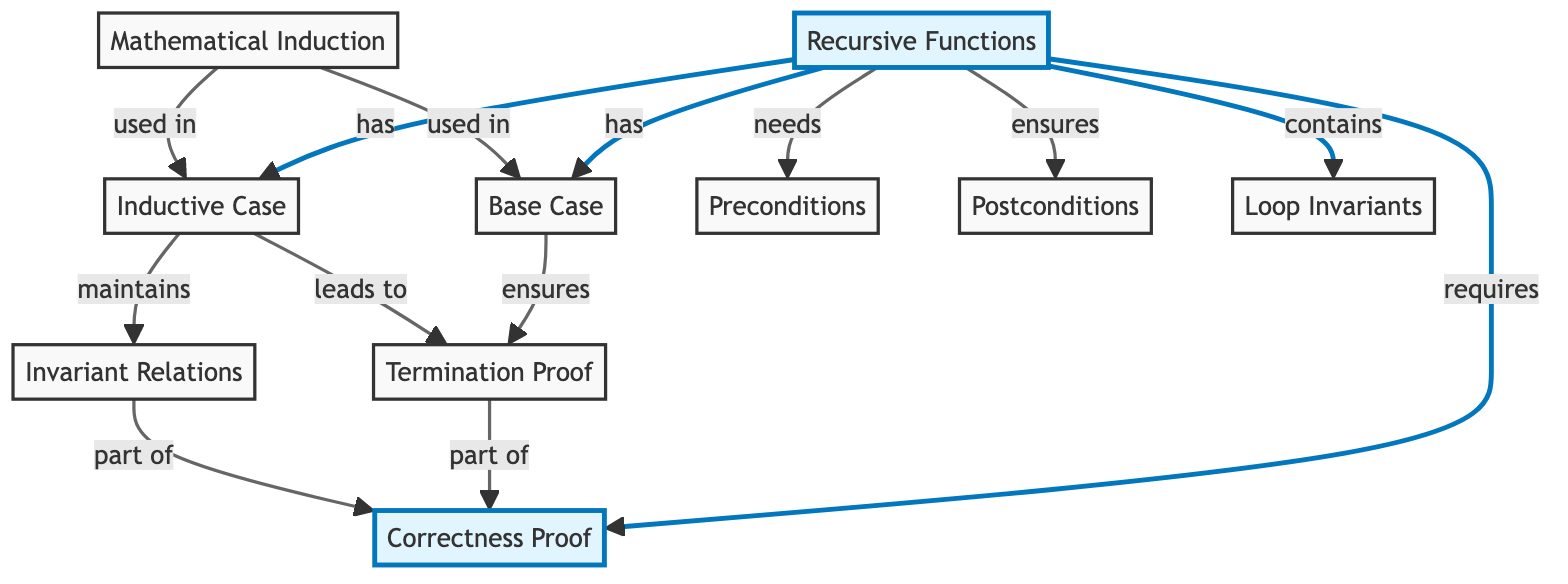What node describes the condition under which recursive calls stop? The diagram identifies "Base Case" as the node that explains when the recursive calls cease. This can be derived from the label associated with node 2.
Answer: Base Case How many nodes are there in the diagram? By counting the distinct circles in the diagram, there are 10 nodes presented, each representing different concepts related to recursive program correctness.
Answer: 10 What relationship does the "Inductive Case" have with the "Termination Proof"? The relationship indicates that the "Inductive Case" leads to the "Termination Proof," which can be confirmed by examining the link pointing from node 3 (Inductive Case) to node 4 (Termination Proof).
Answer: leads to Which node represents the method used to prove properties in recursion? The "Mathematical Induction" node describes the method that is specifically utilized for proving properties in the base and inductive steps of recursion, as noted in node 8.
Answer: Mathematical Induction What does the "Termination Proof" contribute to within the context of recursion? The "Termination Proof" is part of the broader "Correctness Proof." This relationship is illustrated by the link that connects node 4 (Termination Proof) to node 10 (Correctness Proof).
Answer: part of How many links are present between nodes in the diagram? By counting the arrows that connect nodes, there are 12 links in total that establish various relationships between different concepts of recursion and their correctness.
Answer: 12 Which node maintains invariant relations during the recursion? The "Invariant Relations" node is specified to maintain properties that hold true before and after each recursive call, as outlined in node 7.
Answer: Invariant Relations What is a prerequisite for "Correctness Proof" according to the diagram? The "Correctness Proof" requires both the "Termination Proof" and "Invariant Relations," as evidenced by the arrows leading to node 10 from nodes 4 and 7.
Answer: requires Which concepts are directly associated with "Recursive Functions"? The "Recursive Functions" node is associated with three concepts: "Base Case," "Inductive Case," and "Preconditions," as indicated by the outgoing links from node 1.
Answer: Base Case, Inductive Case, Preconditions 